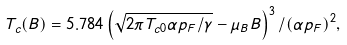Convert formula to latex. <formula><loc_0><loc_0><loc_500><loc_500>T _ { c } ( B ) = 5 . 7 8 4 \left ( \sqrt { 2 \pi T _ { c 0 } \alpha p _ { F } / \gamma } - \mu _ { B } B \right ) ^ { 3 } / ( \alpha p _ { F } ) ^ { 2 } ,</formula> 